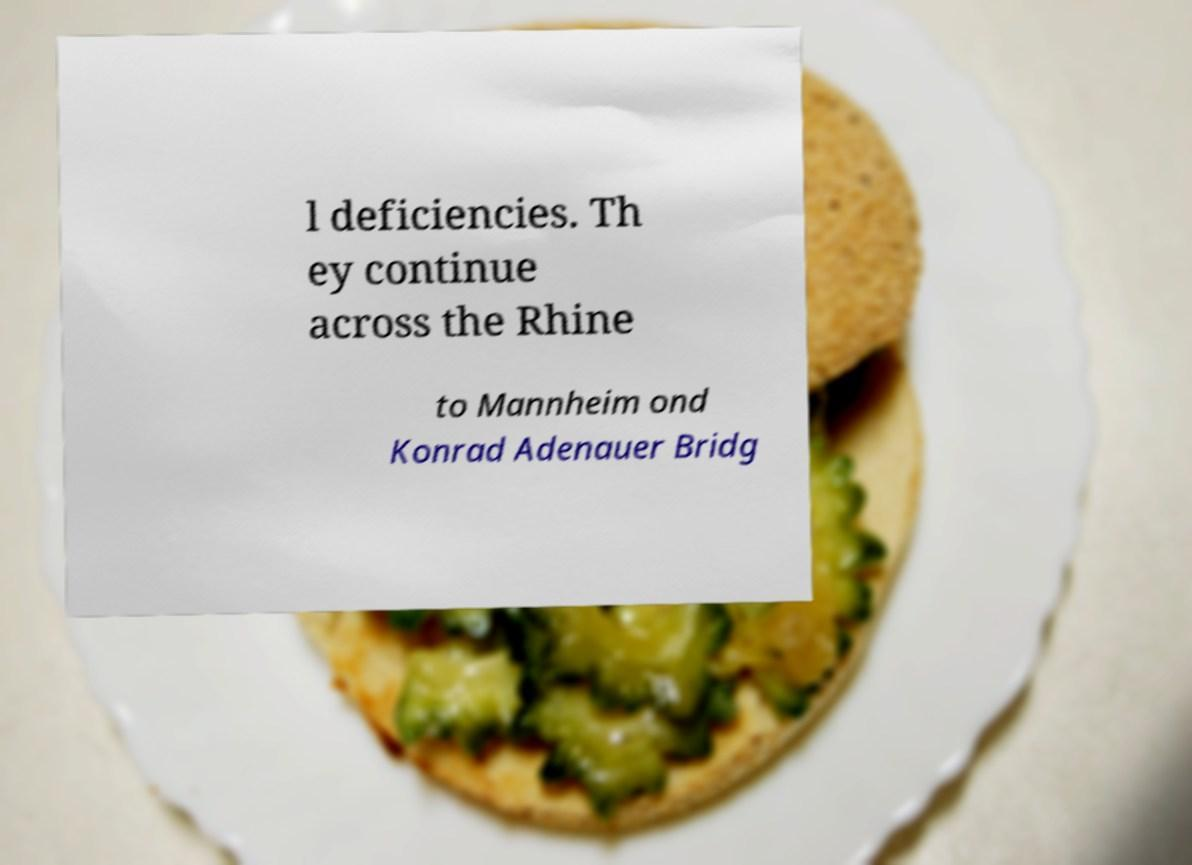Can you read and provide the text displayed in the image?This photo seems to have some interesting text. Can you extract and type it out for me? l deficiencies. Th ey continue across the Rhine to Mannheim ond Konrad Adenauer Bridg 